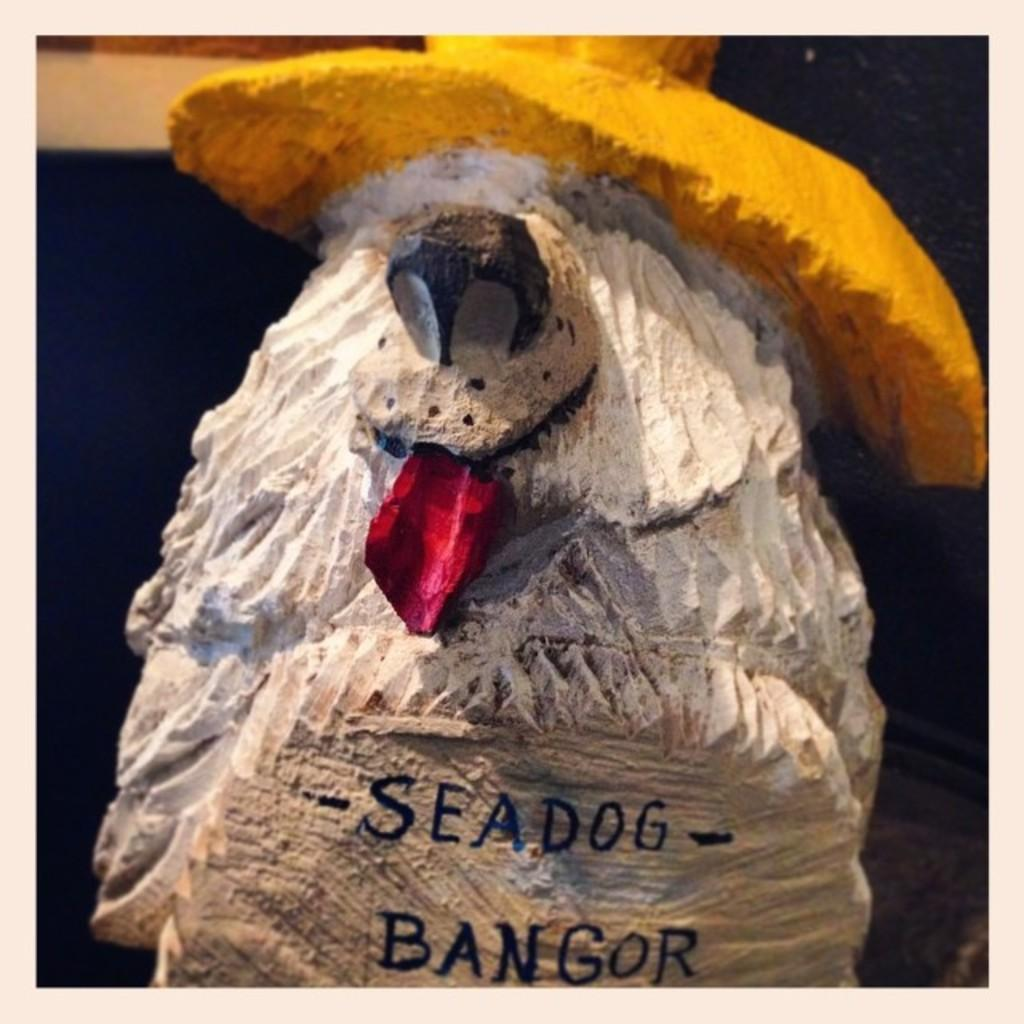What is the main subject of the image? The main subject of the image is a rock. Has the rock been modified in any way? Yes, the rock has been chiselled into the shape of a sea dog. What type of shirt is the porter wearing in the image? There is no porter or shirt present in the image; it features a rock that has been chiselled into the shape of a sea dog. 